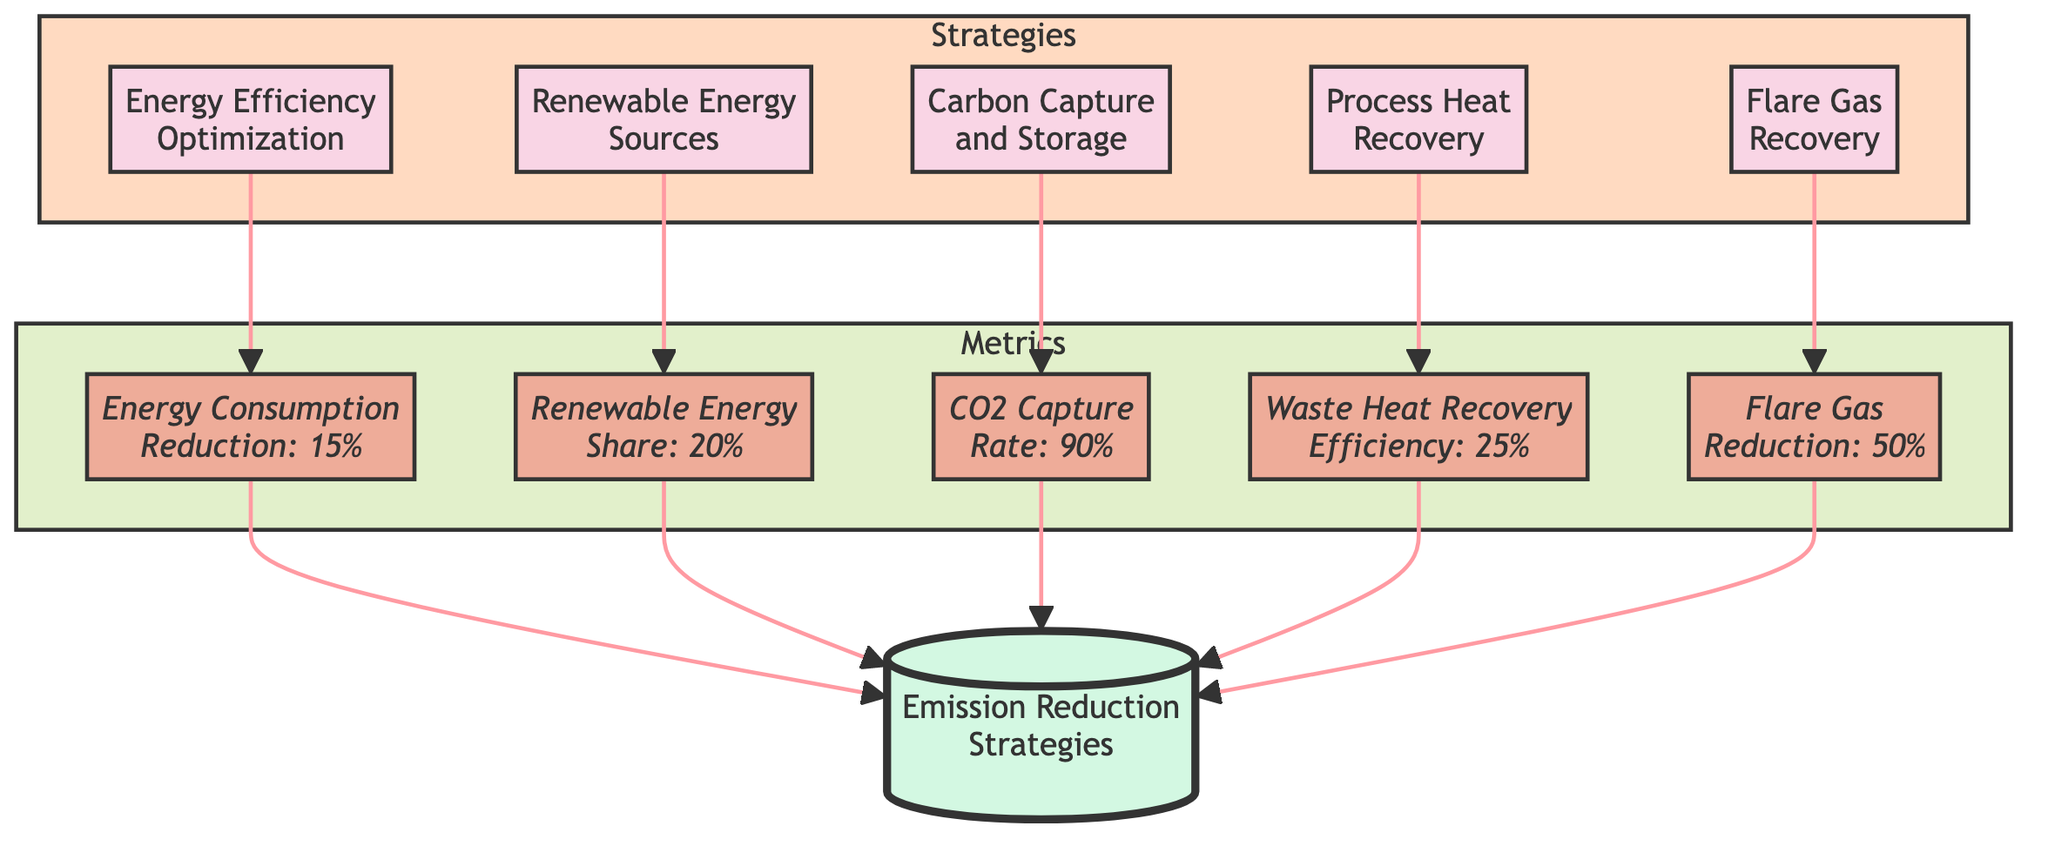What is the target value for Energy Consumption Reduction? The diagram shows that the metric associated with Energy Efficiency Optimization indicates a target value of 15%. Thus, the answer derives directly from the metric associated with Energy Efficiency Optimization.
Answer: 15% What is the strategy involving the reuse of flare gases? Looking at the strategies listed in the diagram, Flare Gas Recovery Systems is the strategy associated with capturing and reusing flare gases.
Answer: Flare Gas Recovery Systems How many different emission reduction strategies are listed? By counting the number of strategies displayed in the diagram, which are Energy Efficiency Optimization, Renewable Energy Sources, Carbon Capture and Storage, Process Heat Recovery, and Flare Gas Recovery, we see that there are five strategies in total.
Answer: 5 What is the CO2 Capture Rate target for Carbon Capture and Storage? The diagram provides the specific target metric for Carbon Capture and Storage which is indicated as 90%. The answer is drawn directly from the metric linked to CCS.
Answer: 90% Which strategy has a target metric of 25%? According to the diagram, the target metric of Waste Heat Recovery Efficiency, which is 25%, corresponds to the Process Heat Recovery strategy. The answer is identified by looking at the specific metrics associated with the strategies.
Answer: Process Heat Recovery If all strategies are implemented, what is the maximum CO2 reduction expected? The only strategy listed that directly correlates with a reduction of CO2 emissions is Carbon Capture and Storage, which targets a CO2 Capture Rate of 90%. Other strategies focus on efficiency and energy reduction, but do not explicitly include CO2 reductions. Therefore, CO2 reduction is primarily represented through the CCS strategy metric.
Answer: 90% What is the relationship between Process Heat Recovery and Waste Heat Recovery Efficiency? The diagram shows that Process Heat Recovery is directly connected to its corresponding metric, Waste Heat Recovery Efficiency, indicating that the latter describes the performance expectation (25%) of the former. Thus, the relationship is one of direct connection leading to metrics related to efficiency of the process.
Answer: Direct connection What strategy is associated with integrating solar or wind power? From the elements shown in the diagram, Renewable Energy Sources pertains to the integration of solar or wind power into the energy mix for liquefaction processes. This answer is found by locating the appropriate strategy within the provided elements.
Answer: Renewable Energy Sources 